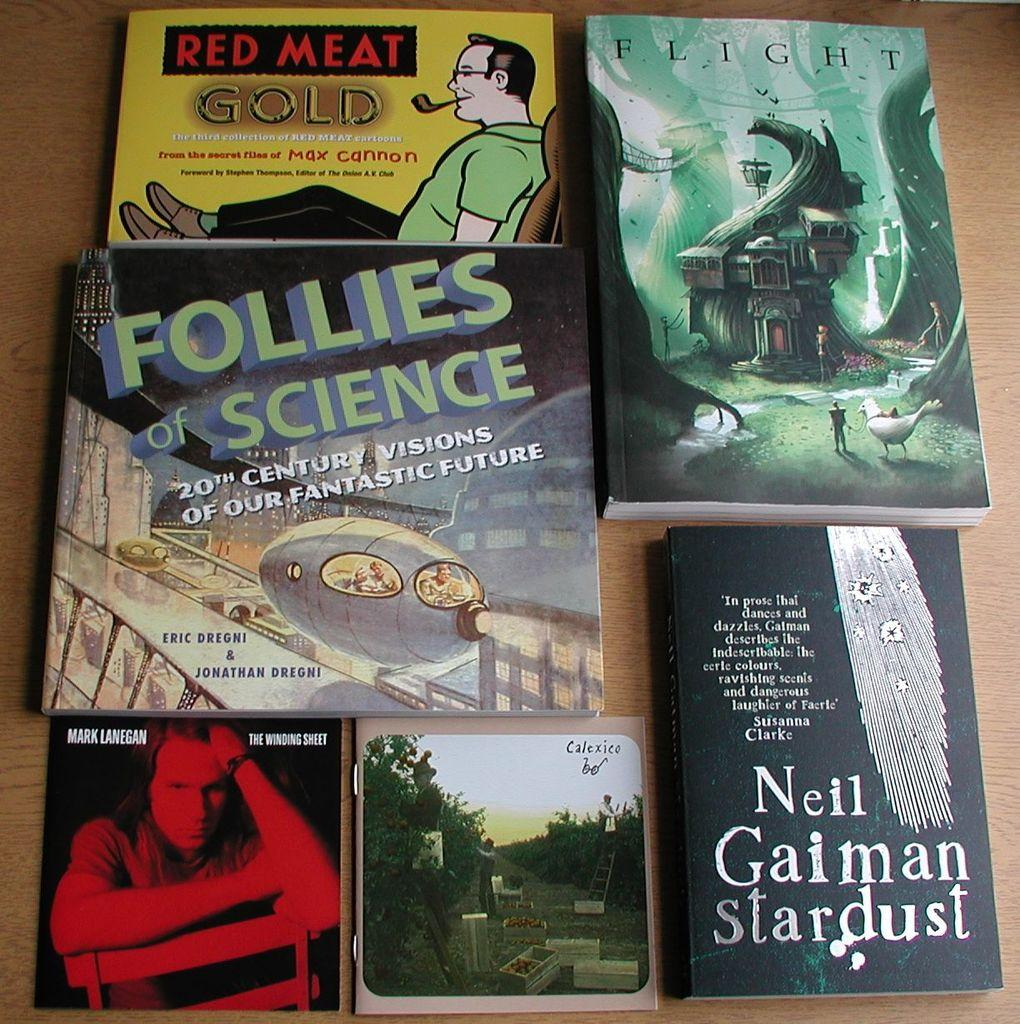<image>
Relay a brief, clear account of the picture shown. the word science is on one of the books among others 